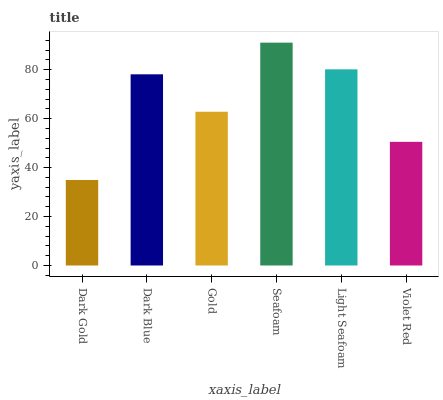Is Dark Gold the minimum?
Answer yes or no. Yes. Is Seafoam the maximum?
Answer yes or no. Yes. Is Dark Blue the minimum?
Answer yes or no. No. Is Dark Blue the maximum?
Answer yes or no. No. Is Dark Blue greater than Dark Gold?
Answer yes or no. Yes. Is Dark Gold less than Dark Blue?
Answer yes or no. Yes. Is Dark Gold greater than Dark Blue?
Answer yes or no. No. Is Dark Blue less than Dark Gold?
Answer yes or no. No. Is Dark Blue the high median?
Answer yes or no. Yes. Is Gold the low median?
Answer yes or no. Yes. Is Violet Red the high median?
Answer yes or no. No. Is Dark Gold the low median?
Answer yes or no. No. 